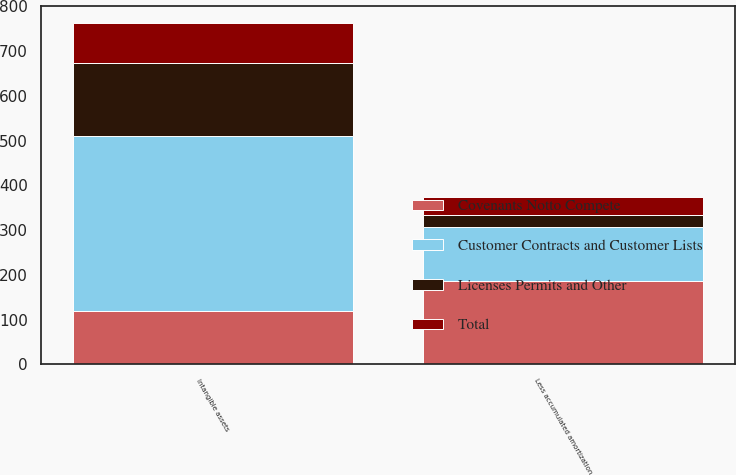Convert chart to OTSL. <chart><loc_0><loc_0><loc_500><loc_500><stacked_bar_chart><ecel><fcel>Intangible assets<fcel>Less accumulated amortization<nl><fcel>Customer Contracts and Customer Lists<fcel>392<fcel>119<nl><fcel>Total<fcel>91<fcel>41<nl><fcel>Licenses Permits and Other<fcel>161<fcel>27<nl><fcel>Covenants Notto Compete<fcel>119<fcel>187<nl></chart> 